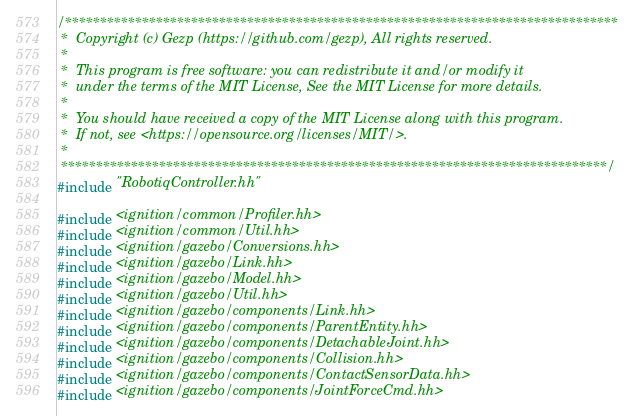Convert code to text. <code><loc_0><loc_0><loc_500><loc_500><_C++_>/*******************************************************************************
 *  Copyright (c) Gezp (https://github.com/gezp), All rights reserved.
 *
 *  This program is free software: you can redistribute it and/or modify it 
 *  under the terms of the MIT License, See the MIT License for more details.
 *
 *  You should have received a copy of the MIT License along with this program.
 *  If not, see <https://opensource.org/licenses/MIT/>.
 *
 ******************************************************************************/
#include "RobotiqController.hh"

#include <ignition/common/Profiler.hh>
#include <ignition/common/Util.hh>
#include <ignition/gazebo/Conversions.hh>
#include <ignition/gazebo/Link.hh>
#include <ignition/gazebo/Model.hh>
#include <ignition/gazebo/Util.hh>
#include <ignition/gazebo/components/Link.hh>
#include <ignition/gazebo/components/ParentEntity.hh>
#include <ignition/gazebo/components/DetachableJoint.hh>
#include <ignition/gazebo/components/Collision.hh>
#include <ignition/gazebo/components/ContactSensorData.hh>
#include <ignition/gazebo/components/JointForceCmd.hh></code> 